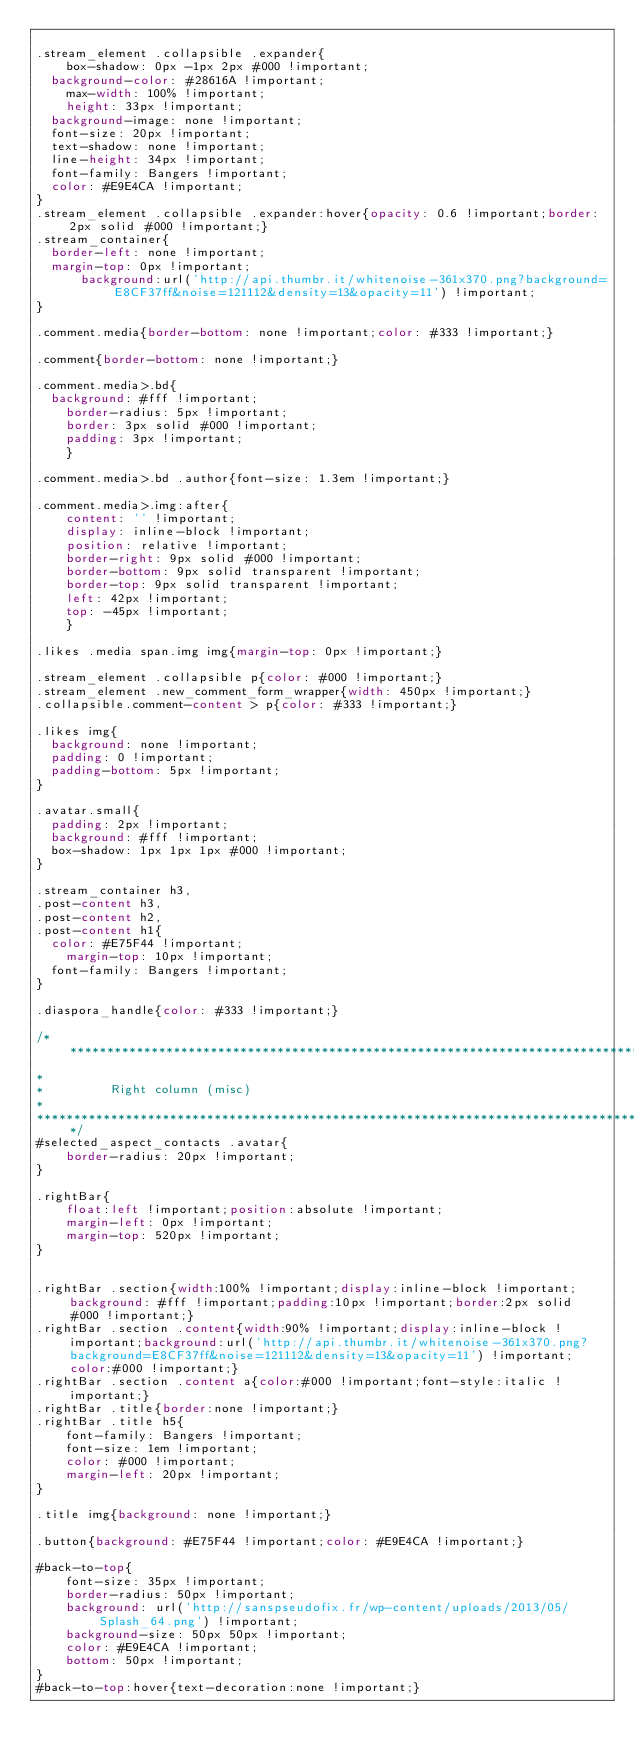<code> <loc_0><loc_0><loc_500><loc_500><_CSS_>
.stream_element .collapsible .expander{
    box-shadow: 0px -1px 2px #000 !important;
	background-color: #28616A !important;
    max-width: 100% !important;
    height: 33px !important;
	background-image: none !important;
	font-size: 20px !important;
	text-shadow: none !important;
	line-height: 34px !important;
	font-family: Bangers !important;
	color: #E9E4CA !important;
}
.stream_element .collapsible .expander:hover{opacity: 0.6 !important;border: 2px solid #000 !important;}
.stream_container{
	border-left: none !important;
	margin-top: 0px !important;
      background:url('http://api.thumbr.it/whitenoise-361x370.png?background=E8CF37ff&noise=121112&density=13&opacity=11') !important;
}

.comment.media{border-bottom: none !important;color: #333 !important;}

.comment{border-bottom: none !important;}

.comment.media>.bd{
	background: #fff !important;
    border-radius: 5px !important;
    border: 3px solid #000 !important;
    padding: 3px !important;
    }

.comment.media>.bd .author{font-size: 1.3em !important;}
    
.comment.media>.img:after{
    content: '' !important;
    display: inline-block !important;
    position: relative !important;
    border-right: 9px solid #000 !important;
    border-bottom: 9px solid transparent !important;
    border-top: 9px solid transparent !important;
    left: 42px !important;
    top: -45px !important;
    }
    
.likes .media span.img img{margin-top: 0px !important;}

.stream_element .collapsible p{color: #000 !important;}
.stream_element .new_comment_form_wrapper{width: 450px !important;}
.collapsible.comment-content > p{color: #333 !important;}

.likes img{
	background: none !important;
	padding: 0 !important;
	padding-bottom: 5px !important;
}

.avatar.small{
	padding: 2px !important;
	background: #fff !important;
	box-shadow: 1px 1px 1px #000 !important;
}

.stream_container h3,
.post-content h3,
.post-content h2,
.post-content h1{
	color: #E75F44 !important;
    margin-top: 10px !important;
	font-family: Bangers !important;
}

.diaspora_handle{color: #333 !important;}

/*****************************************************************************************
*
*					Right column (misc)
*
*******************************************************************************************/
#selected_aspect_contacts .avatar{
    border-radius: 20px !important;
}

.rightBar{
    float:left !important;position:absolute !important;
    margin-left: 0px !important;
    margin-top: 520px !important;
}


.rightBar .section{width:100% !important;display:inline-block !important;background: #fff !important;padding:10px !important;border:2px solid #000 !important;}
.rightBar .section .content{width:90% !important;display:inline-block !important;background:url('http://api.thumbr.it/whitenoise-361x370.png?background=E8CF37ff&noise=121112&density=13&opacity=11') !important;color:#000 !important;}
.rightBar .section .content a{color:#000 !important;font-style:italic !important;}
.rightBar .title{border:none !important;}
.rightBar .title h5{
    font-family: Bangers !important;
    font-size: 1em !important;
    color: #000 !important;
    margin-left: 20px !important;
}

.title img{background: none !important;}

.button{background: #E75F44 !important;color: #E9E4CA !important;}

#back-to-top{
    font-size: 35px !important;
    border-radius: 50px !important;
    background: url('http://sanspseudofix.fr/wp-content/uploads/2013/05/Splash_64.png') !important;
    background-size: 50px 50px !important;
    color: #E9E4CA !important;
    bottom: 50px !important;
}
#back-to-top:hover{text-decoration:none !important;}</code> 